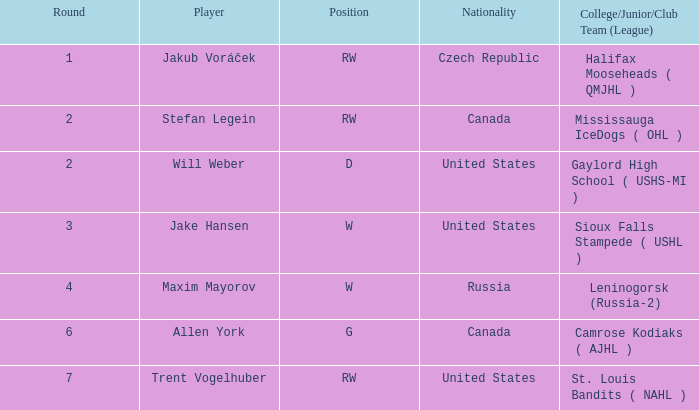What nationality is the draft pick with w position from leninogorsk (russia-2)? Russia. 